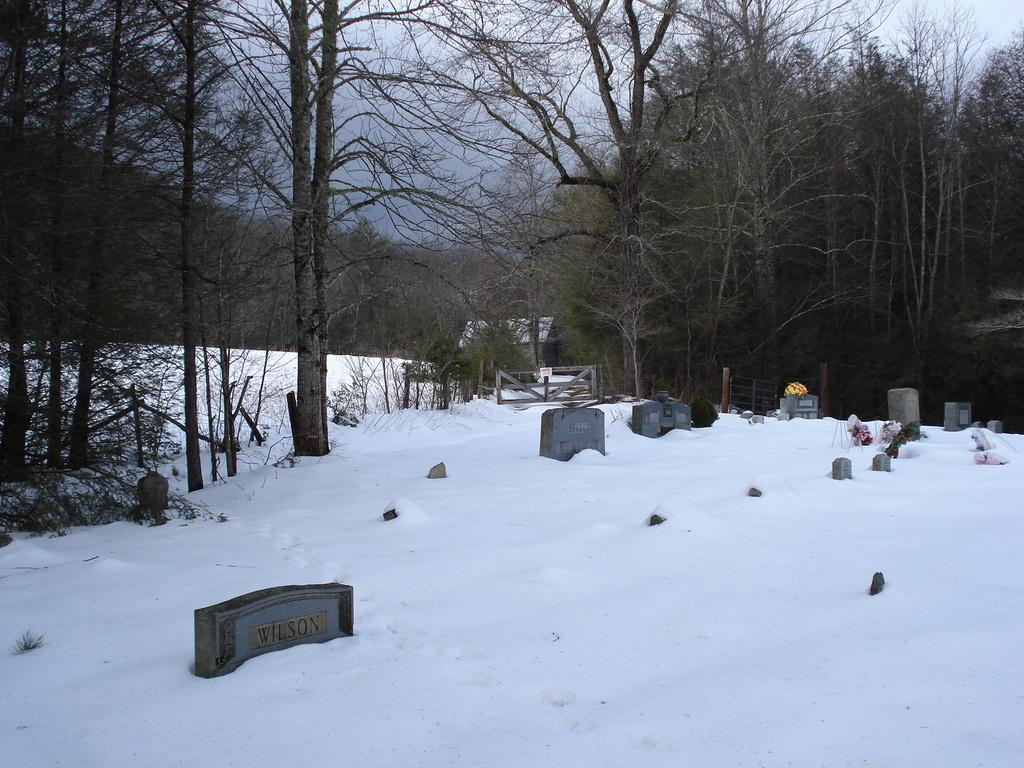What type of objects can be seen on the snow in the image? There are objects on the snow in the image. What is the primary subject of the image? There are tombstones in the image. What can be seen in the background of the image? There is a shed, trees, and the sky visible in the background of the image. What type of war is being fought in the image? There is no war depicted in the image; it features tombstones, objects on the snow, and a background with a shed, trees, and the sky. What do you believe the people buried in the tombstones believed in? The image does not provide any information about the beliefs of the people buried in the tombstones, so it cannot be determined from the image. 